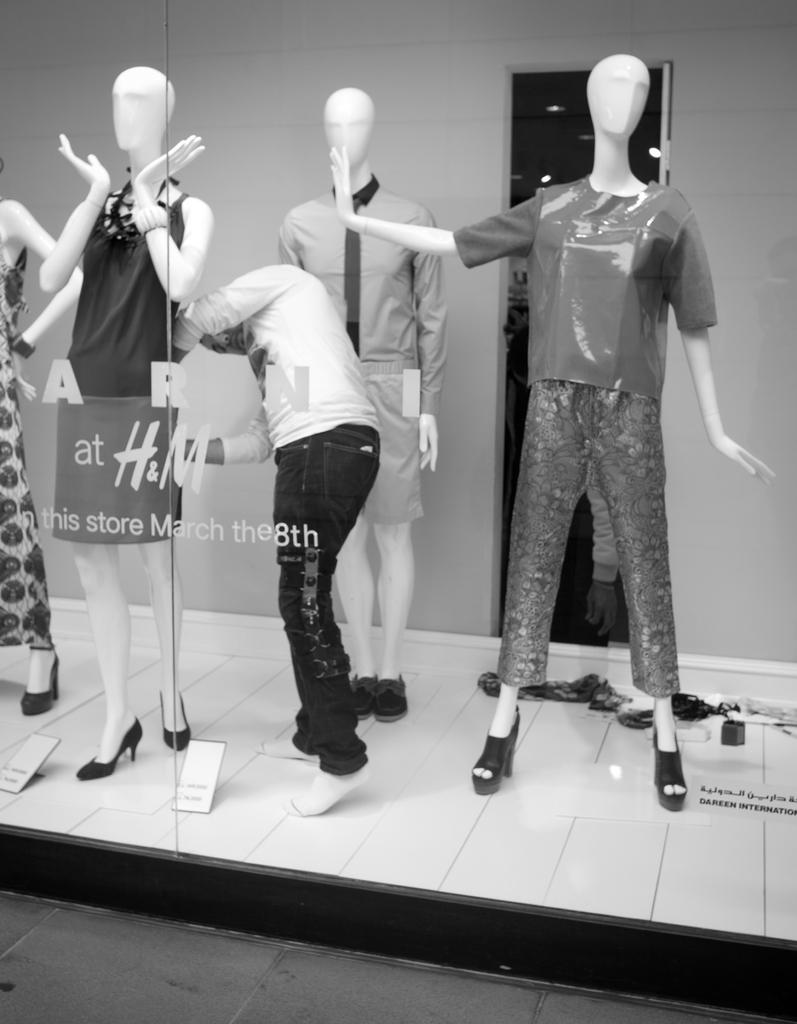What type of objects are the mannequins wearing in the image? The mannequins are wearing dresses in the image. Where are the mannequins located? The mannequins are inside a store. Can you describe the person in the image? There is a person standing in the middle of the image. What is visible in the front of the image? There is a road in the front of the image. What is the color scheme of the image? The image is black and white. What type of tin can be seen being lifted by the person in the image? There is no tin or lifting activity present in the image. What time does the watch on the mannequin's wrist display in the image? There are no watches visible on the mannequins in the image. 